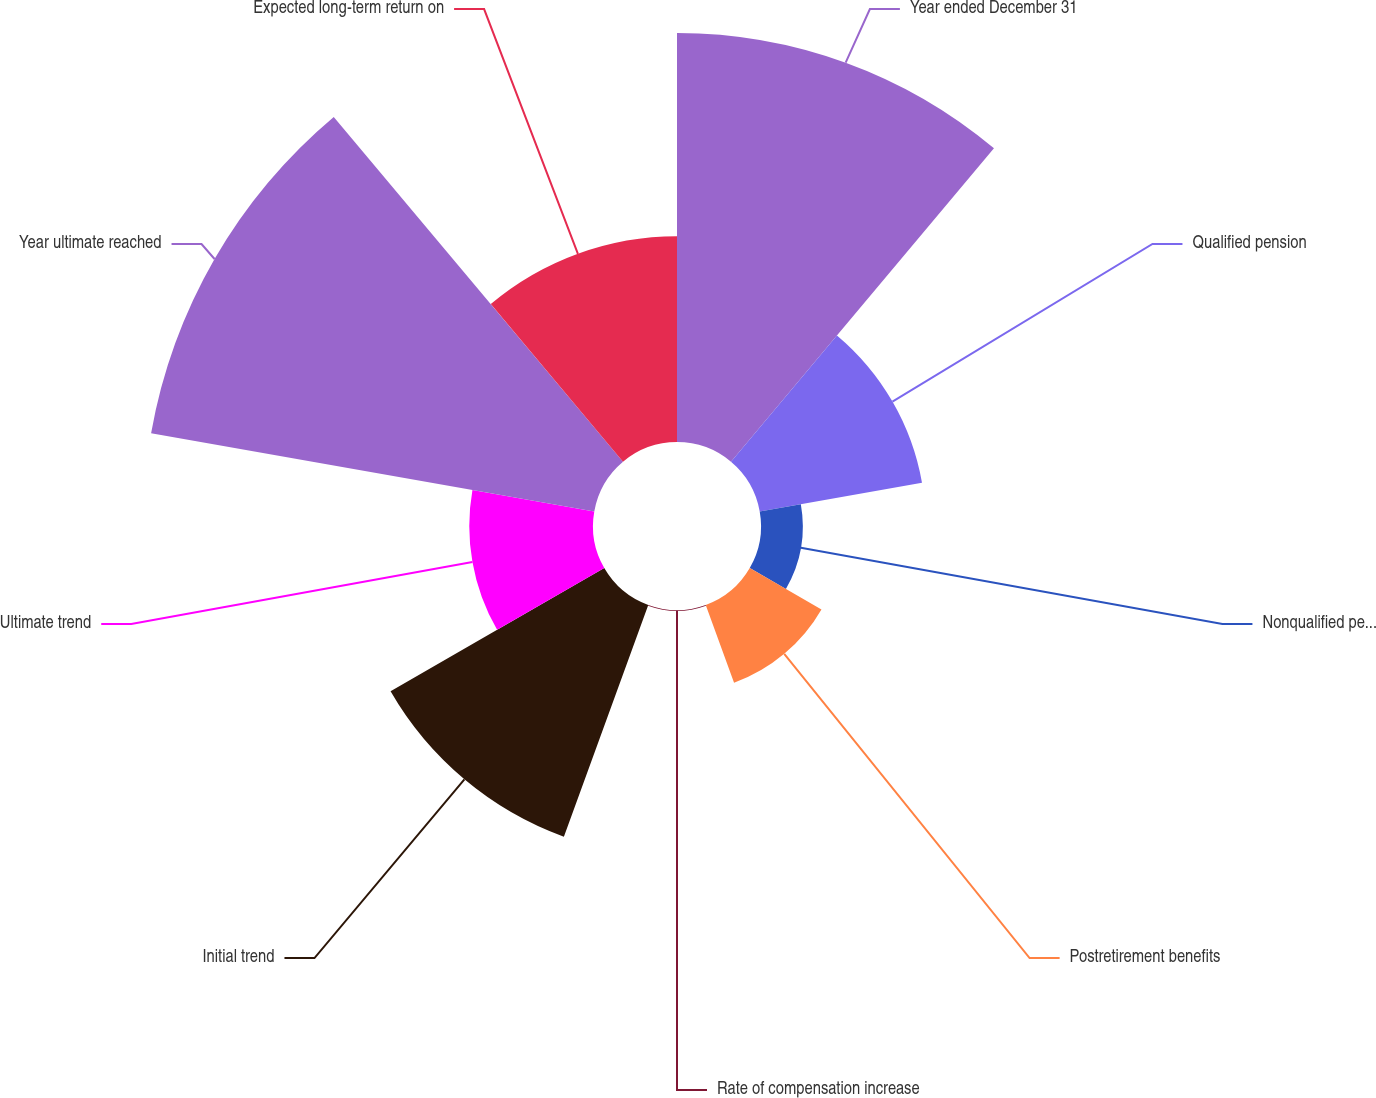Convert chart. <chart><loc_0><loc_0><loc_500><loc_500><pie_chart><fcel>Year ended December 31<fcel>Qualified pension<fcel>Nonqualified pension<fcel>Postretirement benefits<fcel>Rate of compensation increase<fcel>Initial trend<fcel>Ultimate trend<fcel>Year ultimate reached<fcel>Expected long-term return on<nl><fcel>23.71%<fcel>9.55%<fcel>2.42%<fcel>4.8%<fcel>0.05%<fcel>14.3%<fcel>7.17%<fcel>26.08%<fcel>11.92%<nl></chart> 